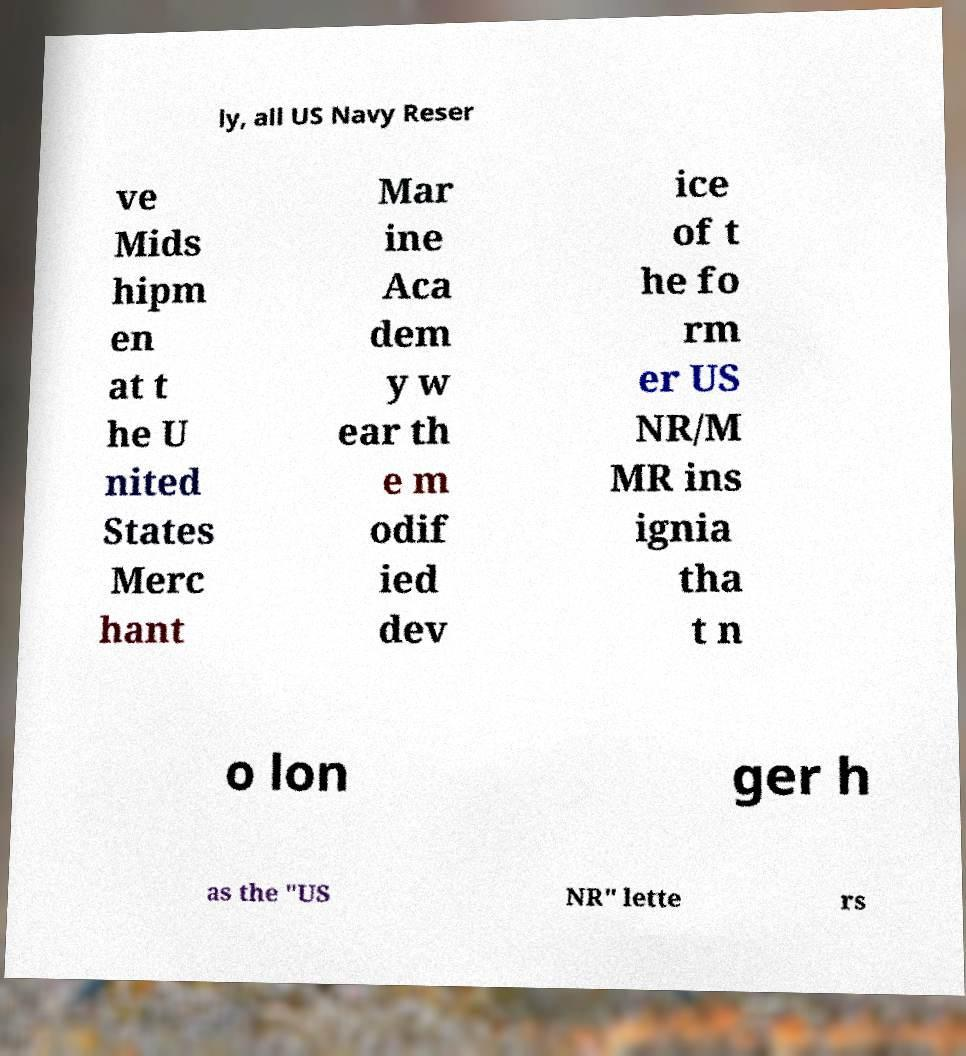Please identify and transcribe the text found in this image. ly, all US Navy Reser ve Mids hipm en at t he U nited States Merc hant Mar ine Aca dem y w ear th e m odif ied dev ice of t he fo rm er US NR/M MR ins ignia tha t n o lon ger h as the "US NR" lette rs 